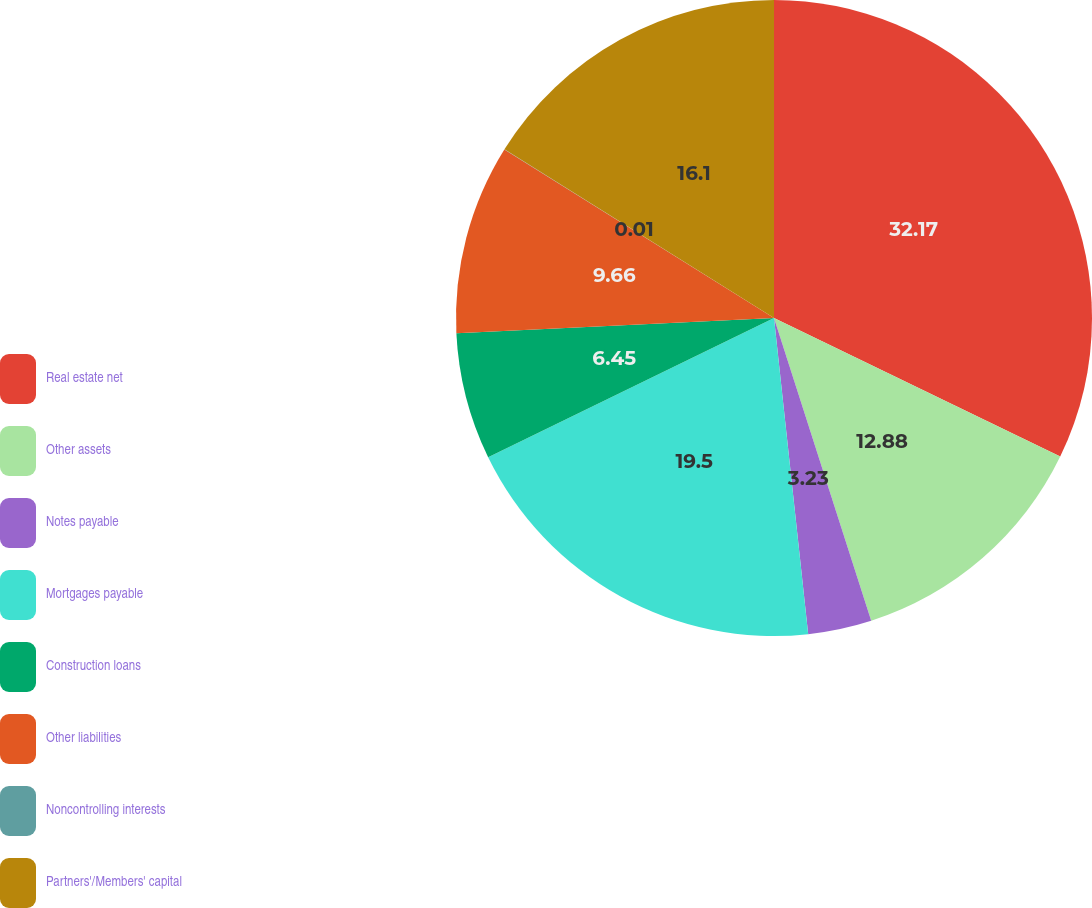Convert chart to OTSL. <chart><loc_0><loc_0><loc_500><loc_500><pie_chart><fcel>Real estate net<fcel>Other assets<fcel>Notes payable<fcel>Mortgages payable<fcel>Construction loans<fcel>Other liabilities<fcel>Noncontrolling interests<fcel>Partners'/Members' capital<nl><fcel>32.18%<fcel>12.88%<fcel>3.23%<fcel>19.5%<fcel>6.45%<fcel>9.66%<fcel>0.01%<fcel>16.1%<nl></chart> 